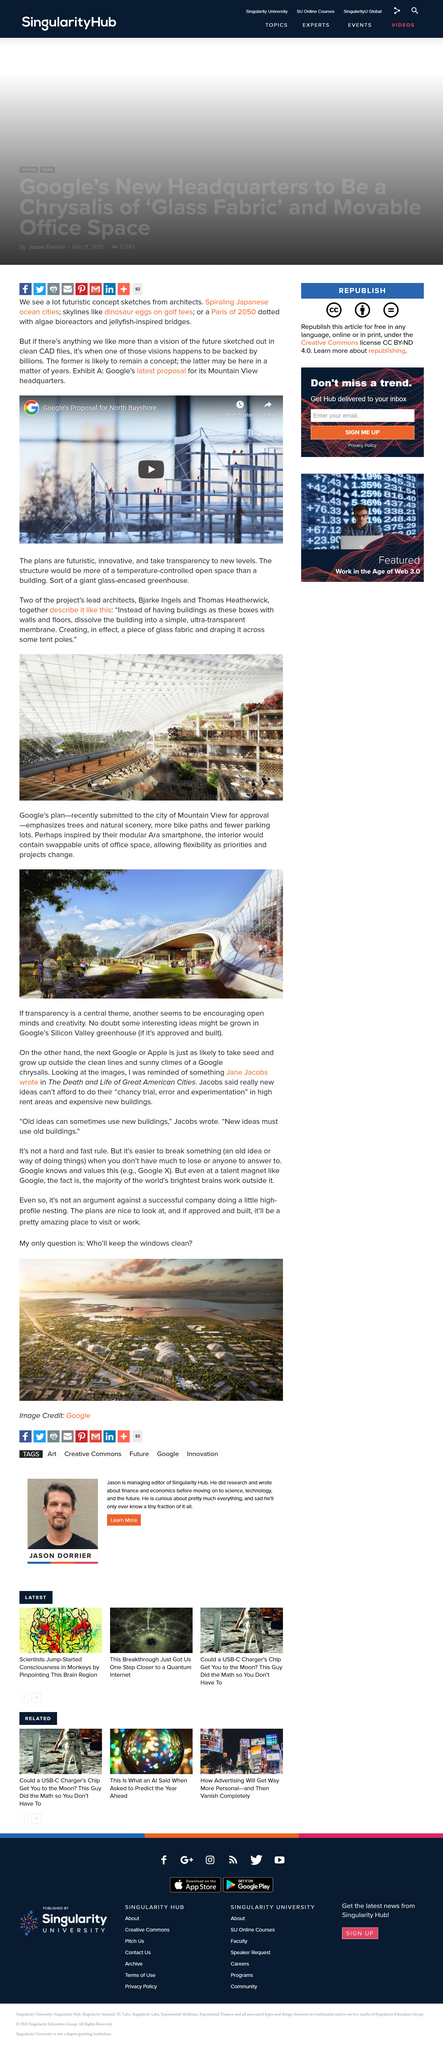Identify some key points in this picture. Jane Jacobs wrote "The Death and Life of Great American Cities. Google's plan includes natural scenery, as stated. The architecture of Thomas Heatherwick is inspired by the Ara smartphone. Yes, Bjarke Ingels is a lead architect. Jane Jacobs argued that in high rent areas, new ideas cannot afford to engage in chancy trial, error and experimentation because it is too risky. 